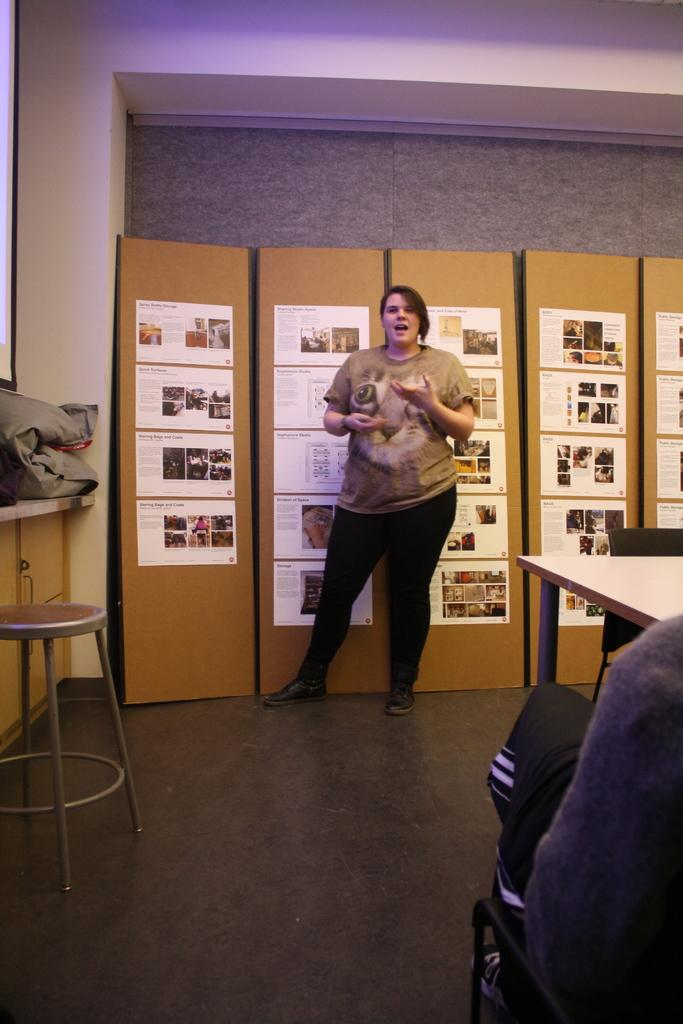Who is present in the image? There is a woman in the image. What is the woman doing in the image? The woman is standing. What type of shoes is the woman wearing in the image? There is no information about the woman's shoes in the image, so we cannot determine what type she is wearing. 